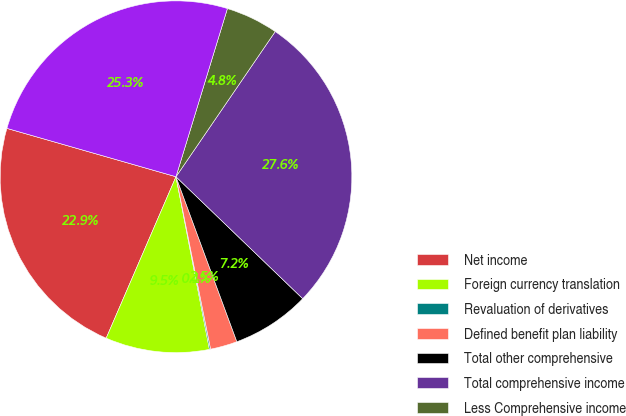Convert chart to OTSL. <chart><loc_0><loc_0><loc_500><loc_500><pie_chart><fcel>Net income<fcel>Foreign currency translation<fcel>Revaluation of derivatives<fcel>Defined benefit plan liability<fcel>Total other comprehensive<fcel>Total comprehensive income<fcel>Less Comprehensive income<fcel>Comprehensive income<nl><fcel>22.94%<fcel>9.54%<fcel>0.11%<fcel>2.47%<fcel>7.18%<fcel>27.65%<fcel>4.82%<fcel>25.29%<nl></chart> 